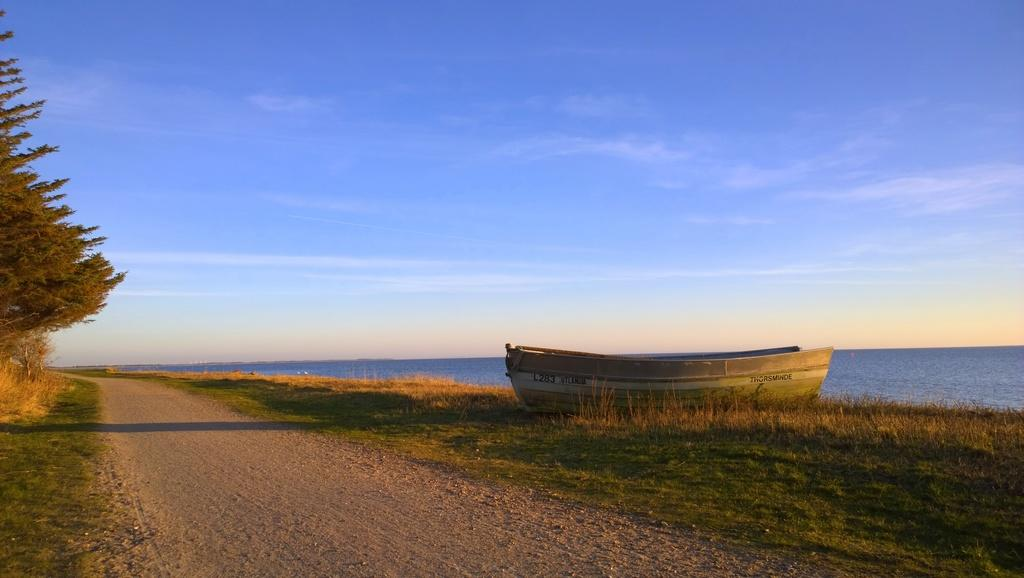What object is on the ground in the image? There is a boat on the ground in the image. What can be seen on the left side of the image? There is a tree on the left side of the image. What is visible in the background of the image? Water and the sky are visible in the background of the image. What type of terrain is at the bottom of the image? There is grass at the bottom of the image. What type of collar is visible on the boat in the image? There is no collar present in the image; it is a boat on the ground. What type of box is being used to store the water in the image? There is no box present in the image; the water is visible in the background. 